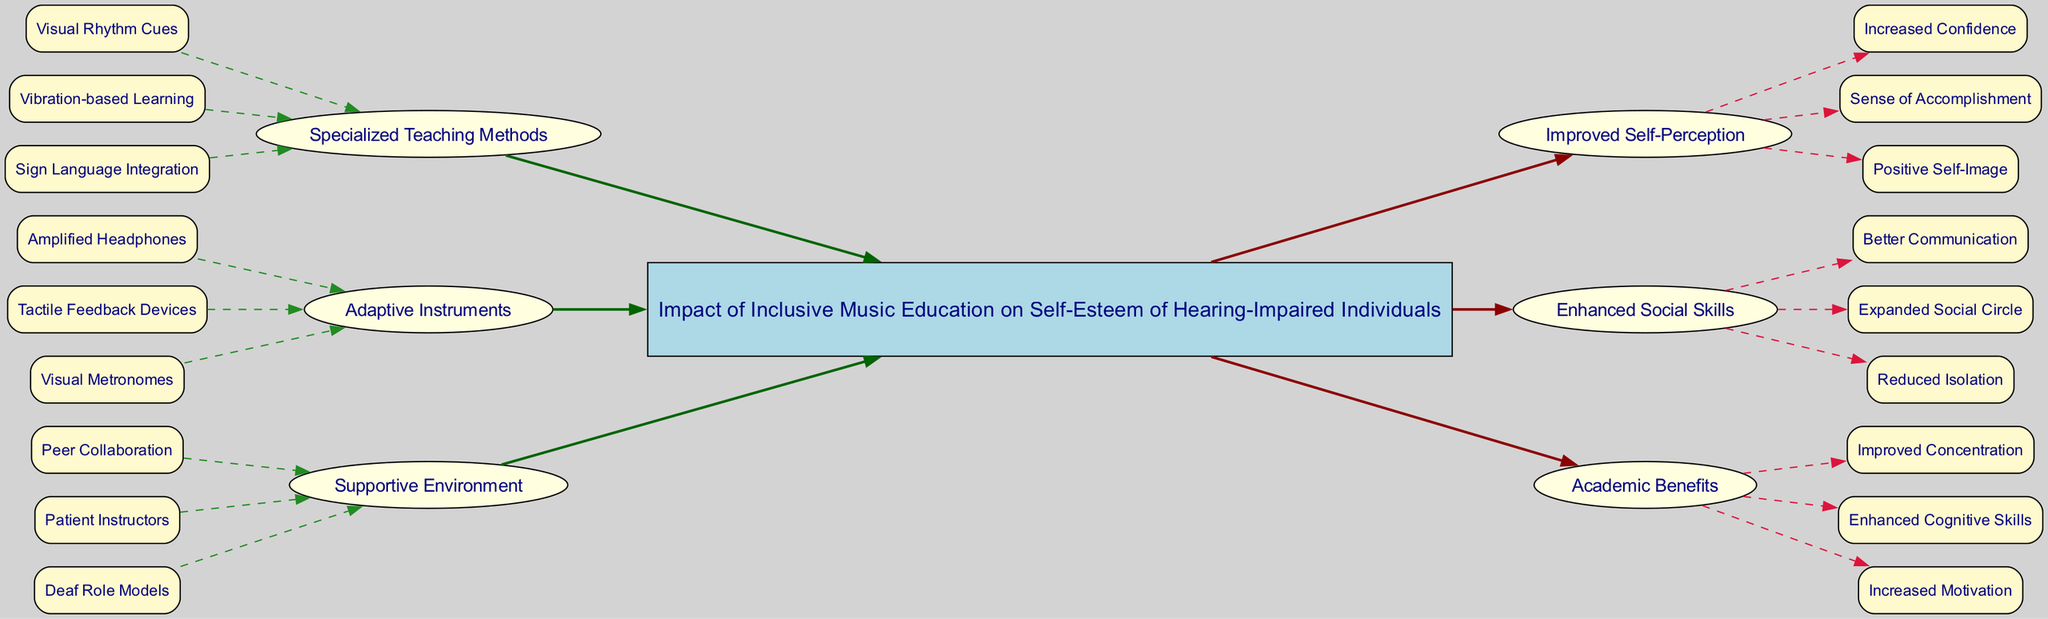What is the central topic of the diagram? The central topic is explicitly labeled at the center of the diagram, and it focuses on the "Impact of Inclusive Music Education on Self-Esteem of Hearing-Impaired Individuals."
Answer: Impact of Inclusive Music Education on Self-Esteem of Hearing-Impaired Individuals How many causes are listed in the diagram? The diagram includes a section labeled "causes," which lists three distinct causes: Specialized Teaching Methods, Adaptive Instruments, and Supportive Environment. By counting these, we determine that there are three causes.
Answer: 3 What is one subcause of Specialized Teaching Methods? Under the category of "Specialized Teaching Methods," there are three subcauses listed. Any one of them can be an answer. For example, "Visual Rhythm Cues" is one of the subcauses.
Answer: Visual Rhythm Cues Which effect is related to improved communication? The effect "Enhanced Social Skills" includes the subeffect "Better Communication," indicating a direct relationship between the educational initiatives and social skills.
Answer: Enhanced Social Skills What is the connection between Adaptive Instruments and Improved Self-Perception? Adaptive Instruments, such as "Amplified Headphones," contribute positively to self-esteem through the effects listed in the right section. This indicates that the connections of causes to effects illustrate how adaptive tools lead to improved self-perception.
Answer: Positive connection How many subeffects are listed under Academic Benefits? The section "Academic Benefits" contains three subeffects: Improved Concentration, Enhanced Cognitive Skills, and Increased Motivation. Count the listed subeffects to arrive at the answer.
Answer: 3 Which cause contributes to the Reduced Isolation effect? The "Supportive Environment" cause fosters Peer Collaboration and Patient Instructors, which collectively promote social interaction, leading to the effect of Reduced Isolation.
Answer: Supportive Environment What color represents the central topic in the diagram? The central topic is marked with a specific node style in the diagram, which uses a light blue background color. This design choice helps it stand out clearly among other nodes.
Answer: Light blue What is the relationship between "Vibration-based Learning" and "Increased Confidence"? The cause "Vibration-based Learning" falls under "Specialized Teaching Methods" and links directly to the effects on the right side, specifically contributing to "Improved Self-Perception," which includes "Increased Confidence."
Answer: Direct relationship 